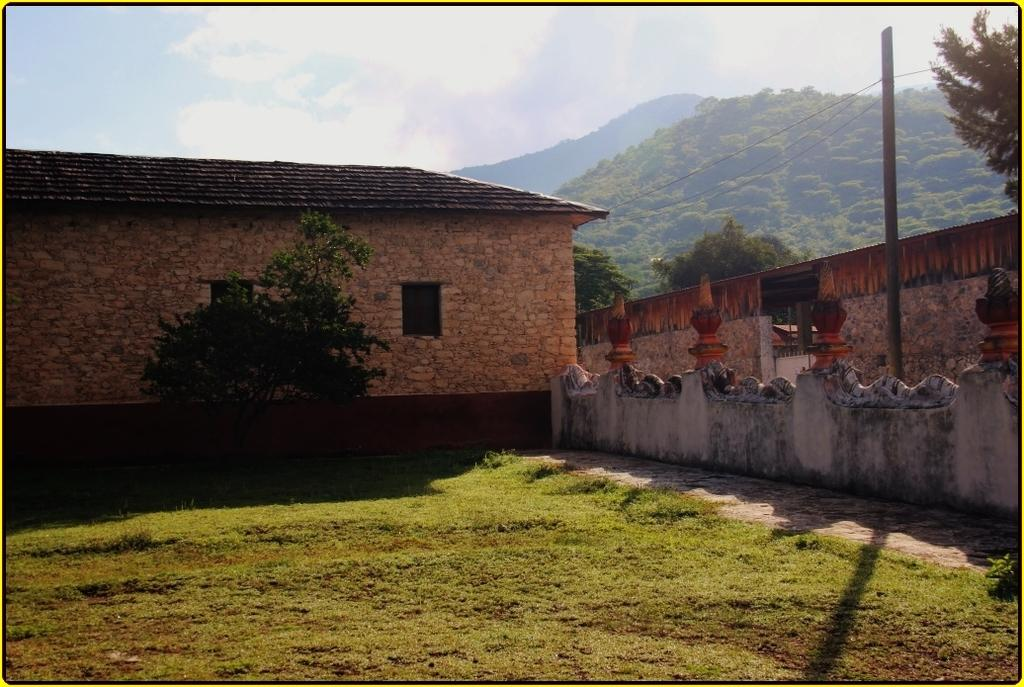What type of structures can be seen in the image? There are houses in the image. What is the background of the image composed of? The image features a wall, trees, hills, grass, and sky. Can you describe the sky in the image? The sky in the image has clouds visible. Where is the lumber shop located in the image? There is no lumber shop present in the image. What memories can be recalled from the image? The image itself does not evoke specific memories, as it is a static representation. 